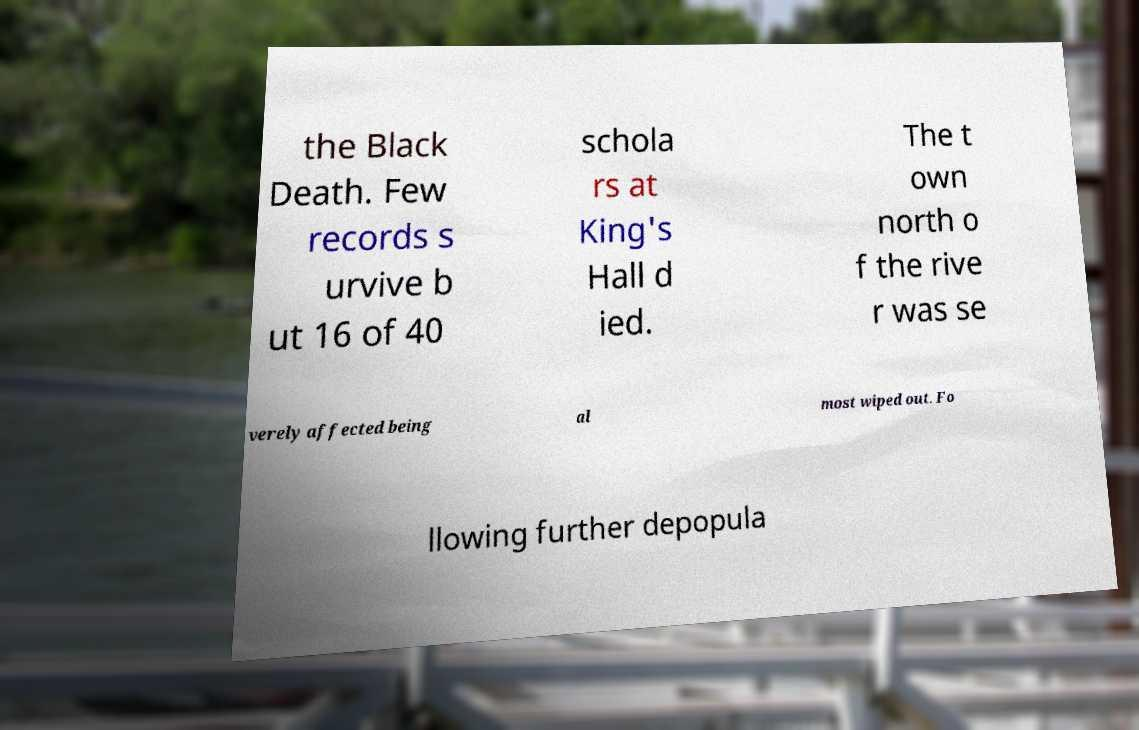Can you read and provide the text displayed in the image?This photo seems to have some interesting text. Can you extract and type it out for me? the Black Death. Few records s urvive b ut 16 of 40 schola rs at King's Hall d ied. The t own north o f the rive r was se verely affected being al most wiped out. Fo llowing further depopula 